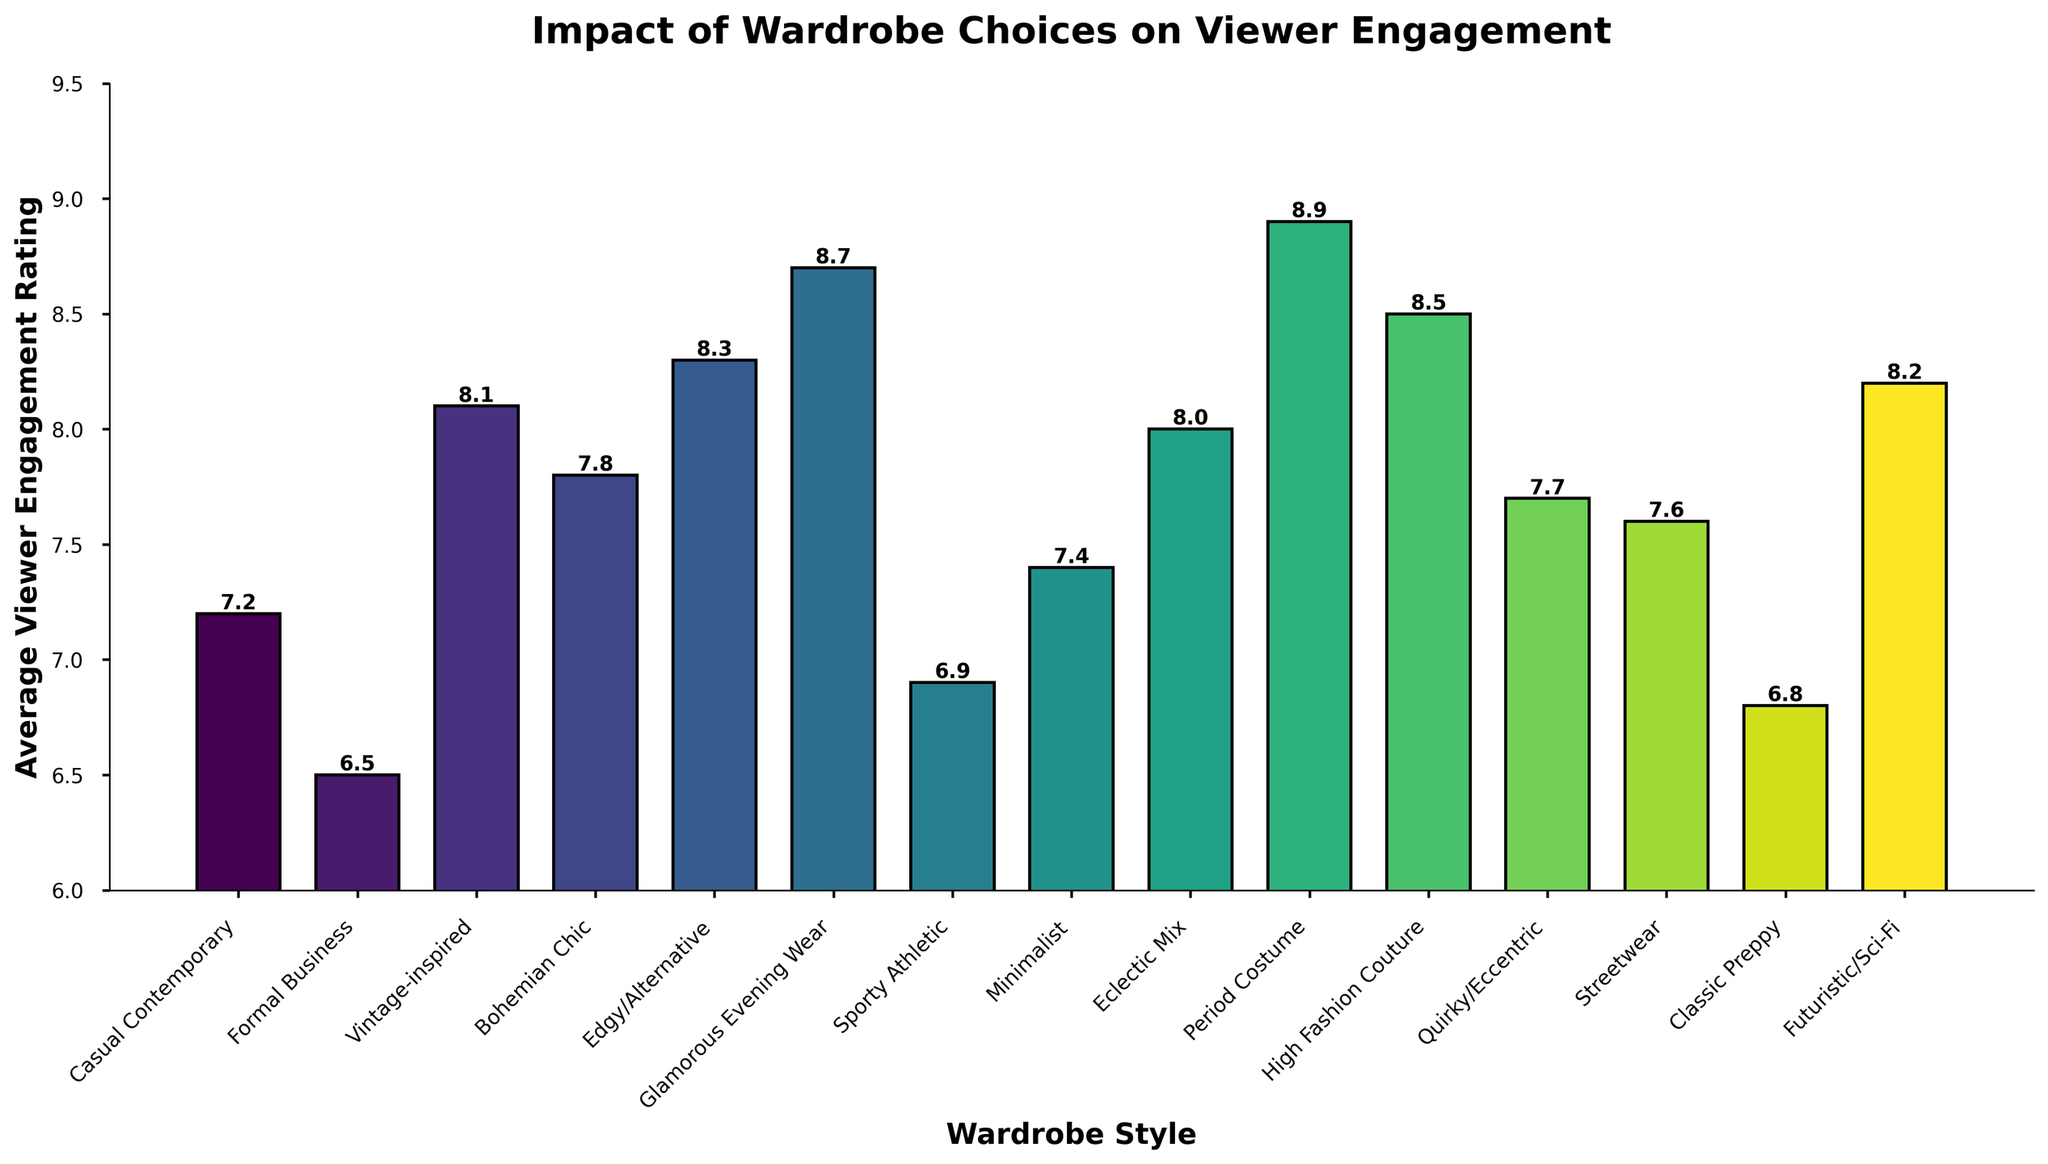What's the wardrobe style with the highest average viewer engagement rating? Identify the bar with the peak height. "Period Costume" reaches 8.9, the highest rating.
Answer: Period Costume Which two wardrobe styles have an average viewer engagement rating of less than 7? Locate bars below the 7 rating on the y-axis. "Formal Business" (6.5) and "Classic Preppy" (6.8) meet this criterion.
Answer: Formal Business, Classic Preppy How much higher is the engagement rating for "Glamorous Evening Wear" compared to "Sporty Athletic"? Subtract "Sporty Athletic" (6.9) from "Glamorous Evening Wear" (8.7): 8.7 - 6.9 = 1.8
Answer: 1.8 Which styles fall into the range of 7.5 to 8.0 in engagement ratings? Identify bars within the 7.5 and 8.0 y-axis range. "Quirky/Eccentric" (7.7), "Streetwear" (7.6), and "Eclectic Mix" (8.0) fit.
Answer: Quirky/Eccentric, Streetwear, Eclectic Mix What's the difference between the highest and the lowest engagement ratings among all wardrobe styles? Subtract the smallest rating (6.5, "Formal Business") from the largest (8.9, "Period Costume"): 8.9 - 6.5 = 2.4
Answer: 2.4 How many wardrobe styles have average viewer engagement ratings above 8? Count the bars exceeding the 8 mark on the y-axis. "Period Costume," "High Fashion Couture," and "Edgy/Alternative," "Vintage-inspired," and "Glamorous Evening Wear" count.
Answer: 5 Which wardrobe styles have a similar rating around 8.2? Locate bars close to 8.2. "Futuristic/Sci-Fi" directly meets this value with 8.2.
Answer: Futuristic/Sci-Fi Is there any wardrobe style with an engagement rating exactly at the midpoint of the range (7.75)? No bar precisely aligns with 7.75 on the y-axis; thus, no style fits this midpoint exactly.
Answer: No What are the visual distinctions of the longest bar in the chart? The tallest, "Period Costume," is notably higher than the rest and marked by its prominent color distinct from shorter bars.
Answer: Period Costume How much greater is the engagement rating of "High Fashion Couture" than "Casual Contemporary"? Subtract "Casual Contemporary" (7.2) from "High Fashion Couture" (8.5): 8.5 - 7.2 = 1.3
Answer: 1.3 